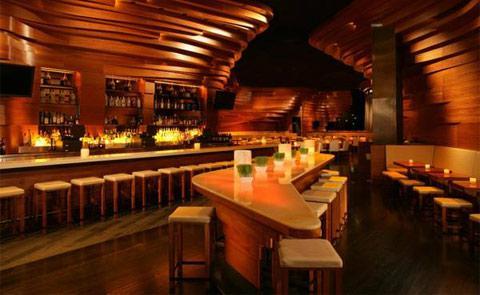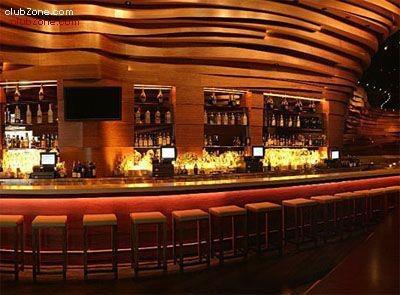The first image is the image on the left, the second image is the image on the right. For the images displayed, is the sentence "The left image shows an interior with lights in a circle suspended from the ceiling, and the right image shows an interior with sculpted curving walls facing rows of seats." factually correct? Answer yes or no. No. The first image is the image on the left, the second image is the image on the right. Assess this claim about the two images: "The left image contains at least one chandelier.". Correct or not? Answer yes or no. No. 